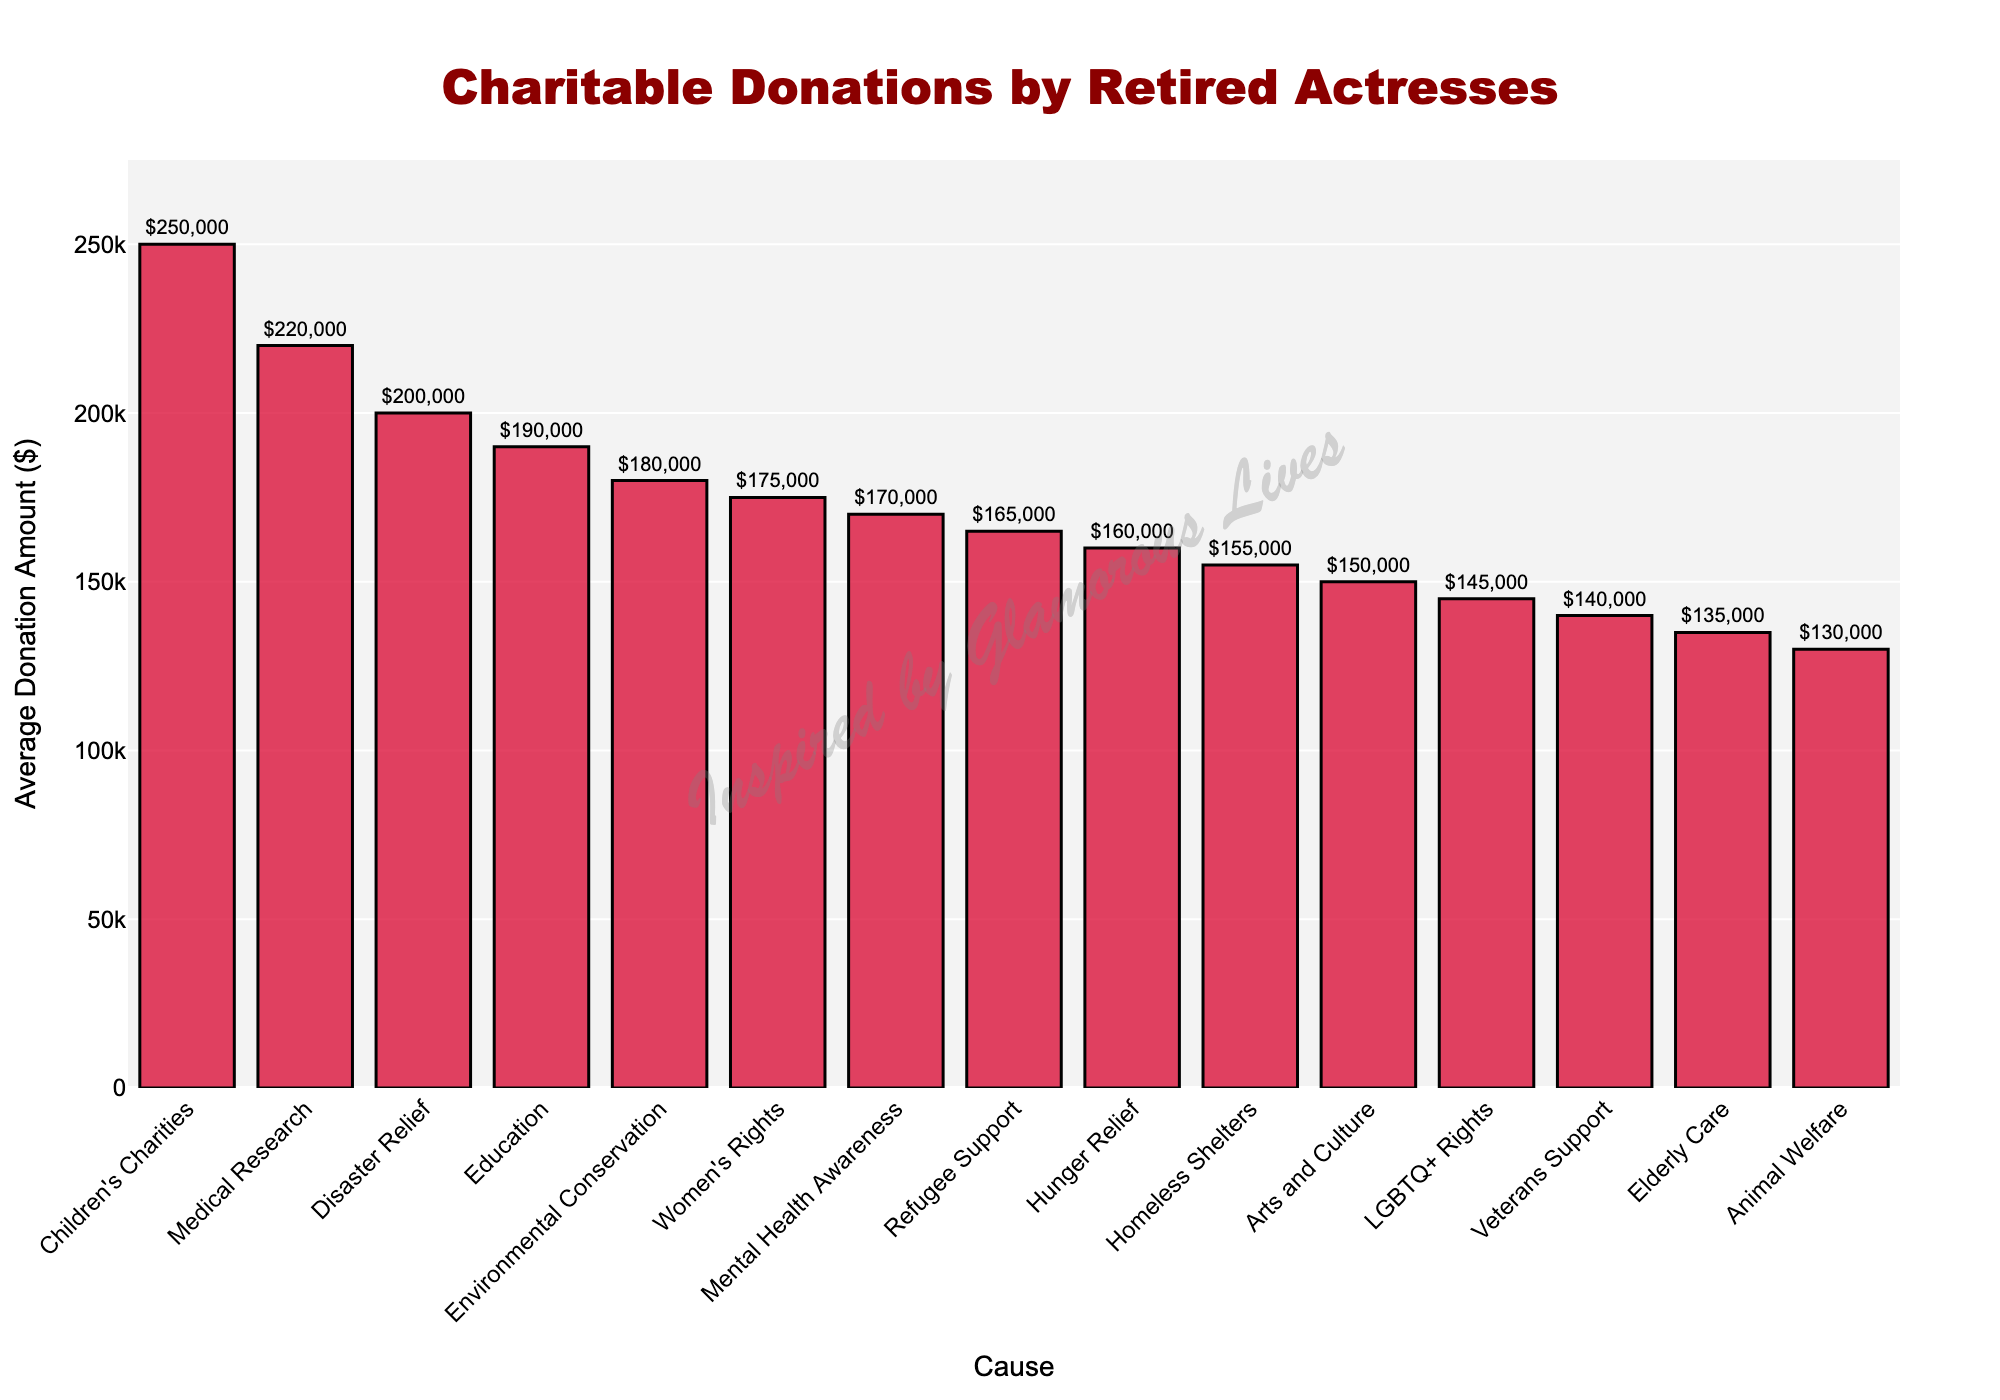What cause received the highest average donation amount? The highest bar represents Children's Charities with an average donation amount of $250,000 as it is the tallest and at the top of the sorted list.
Answer: Children's Charities How much more is the average donation to Children's Charities compared to Animal Welfare? Children's Charities received $250,000 and Animal Welfare received $130,000, so the difference is $250,000 - $130,000 = $120,000.
Answer: $120,000 Which causes received more than $200,000 on average? The bars which extend above the $200,000 line represent causes receiving more than $200,000. These are Children's Charities and Medical Research, along with Disaster Relief which matches $200,000.
Answer: Children's Charities, Medical Research, Disaster Relief Compare the average donation amounts for Education and Environmental Conservation. Education received $190,000 and Environmental Conservation received $180,000. Comparing the two, Education has donated $10,000 more on average than Environmental Conservation.
Answer: Education has $10,000 more What's the total average donation amount for the top three causes? The top three causes are Children's Charities ($250,000), Medical Research ($220,000), and Disaster Relief ($200,000). Adding these values: $250,000 + $220,000 + $200,000 = $670,000.
Answer: $670,000 Which cause received the lowest average donation amount? The shortest bar indicates the cause, which is Animal Welfare with an average donation of $130,000.
Answer: Animal Welfare How does the average donation amount to LGBTQ+ Rights compare to Veterans Support? LGBTQ+ Rights received $145,000 and Veterans Support received $140,000. LGBTQ+ Rights received $5,000 more on average.
Answer: LGBTQ+ Rights received $5,000 more What is the range of the average donation amounts across all causes? The highest average donation is for Children's Charities ($250,000) and the lowest is for Animal Welfare ($130,000). Therefore, the range is $250,000 - $130,000 = $120,000.
Answer: $120,000 What's the combined average donation amount for causes directly related to human welfare such as Hunger Relief, Homeless Shelters, and Mental Health Awareness? Adding these values: Hunger Relief ($160,000) + Homeless Shelters ($155,000) + Mental Health Awareness ($170,000). The combined total is $160,000 + $155,000 + $170,000 = $485,000.
Answer: $485,000 How much more do retired actresses donate on average to Women's Rights compared to Elderly Care? Women's Rights receive $175,000 on average while Elderly Care receives $135,000. The difference is $175,000 - $135,000 = $40,000.
Answer: $40,000 